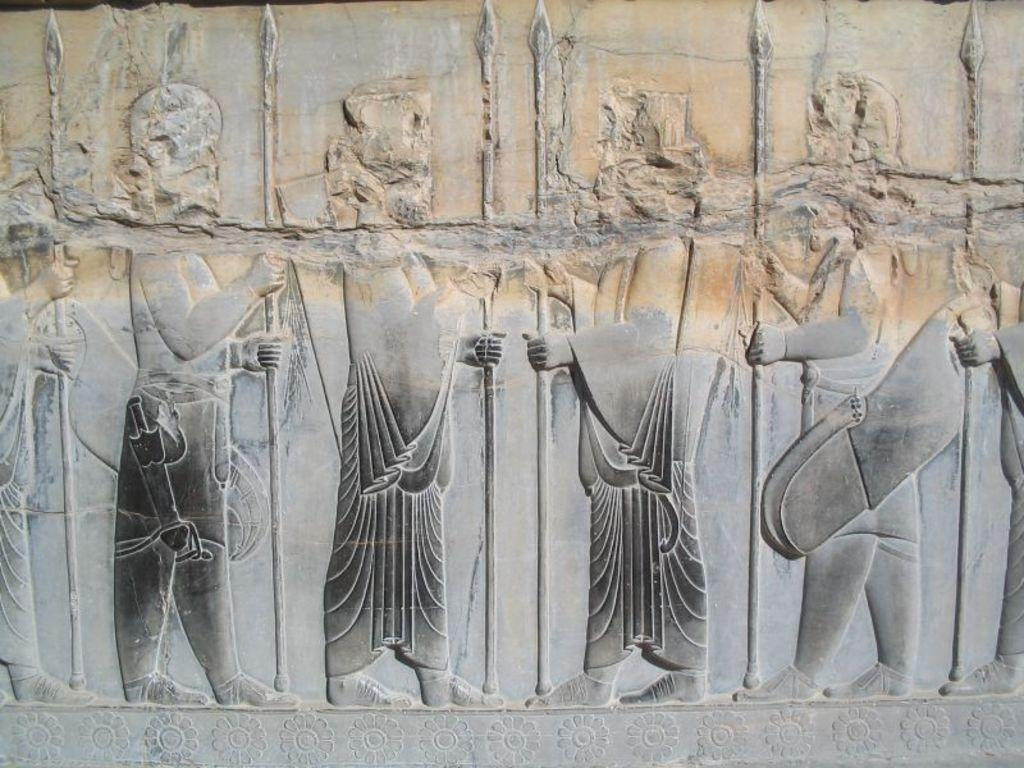What type of sculptures can be seen on the stone? There are sculptures of people on the stone. What are the people sculptures holding in their hands? The people sculptures are holding rods in their hands. What other type of sculptures can be found at the bottom of the stone? There are flower sculptures at the bottom of the stone. What type of calendar is depicted on the stone? There is no calendar present on the stone; it features sculptures of people holding rods and flower sculptures at the bottom. 